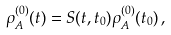<formula> <loc_0><loc_0><loc_500><loc_500>\rho _ { A } ^ { ( 0 ) } ( t ) = S ( t , t _ { 0 } ) \rho _ { A } ^ { ( 0 ) } ( t _ { 0 } ) \, ,</formula> 